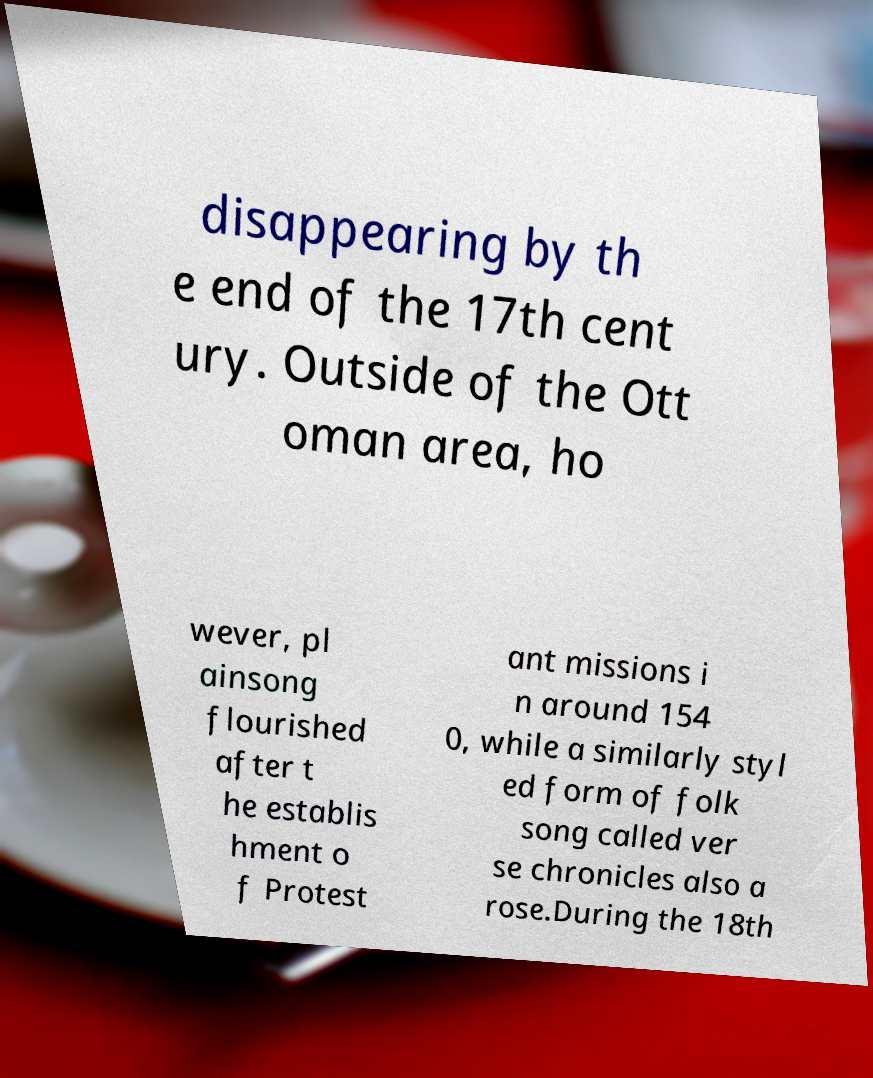There's text embedded in this image that I need extracted. Can you transcribe it verbatim? disappearing by th e end of the 17th cent ury. Outside of the Ott oman area, ho wever, pl ainsong flourished after t he establis hment o f Protest ant missions i n around 154 0, while a similarly styl ed form of folk song called ver se chronicles also a rose.During the 18th 